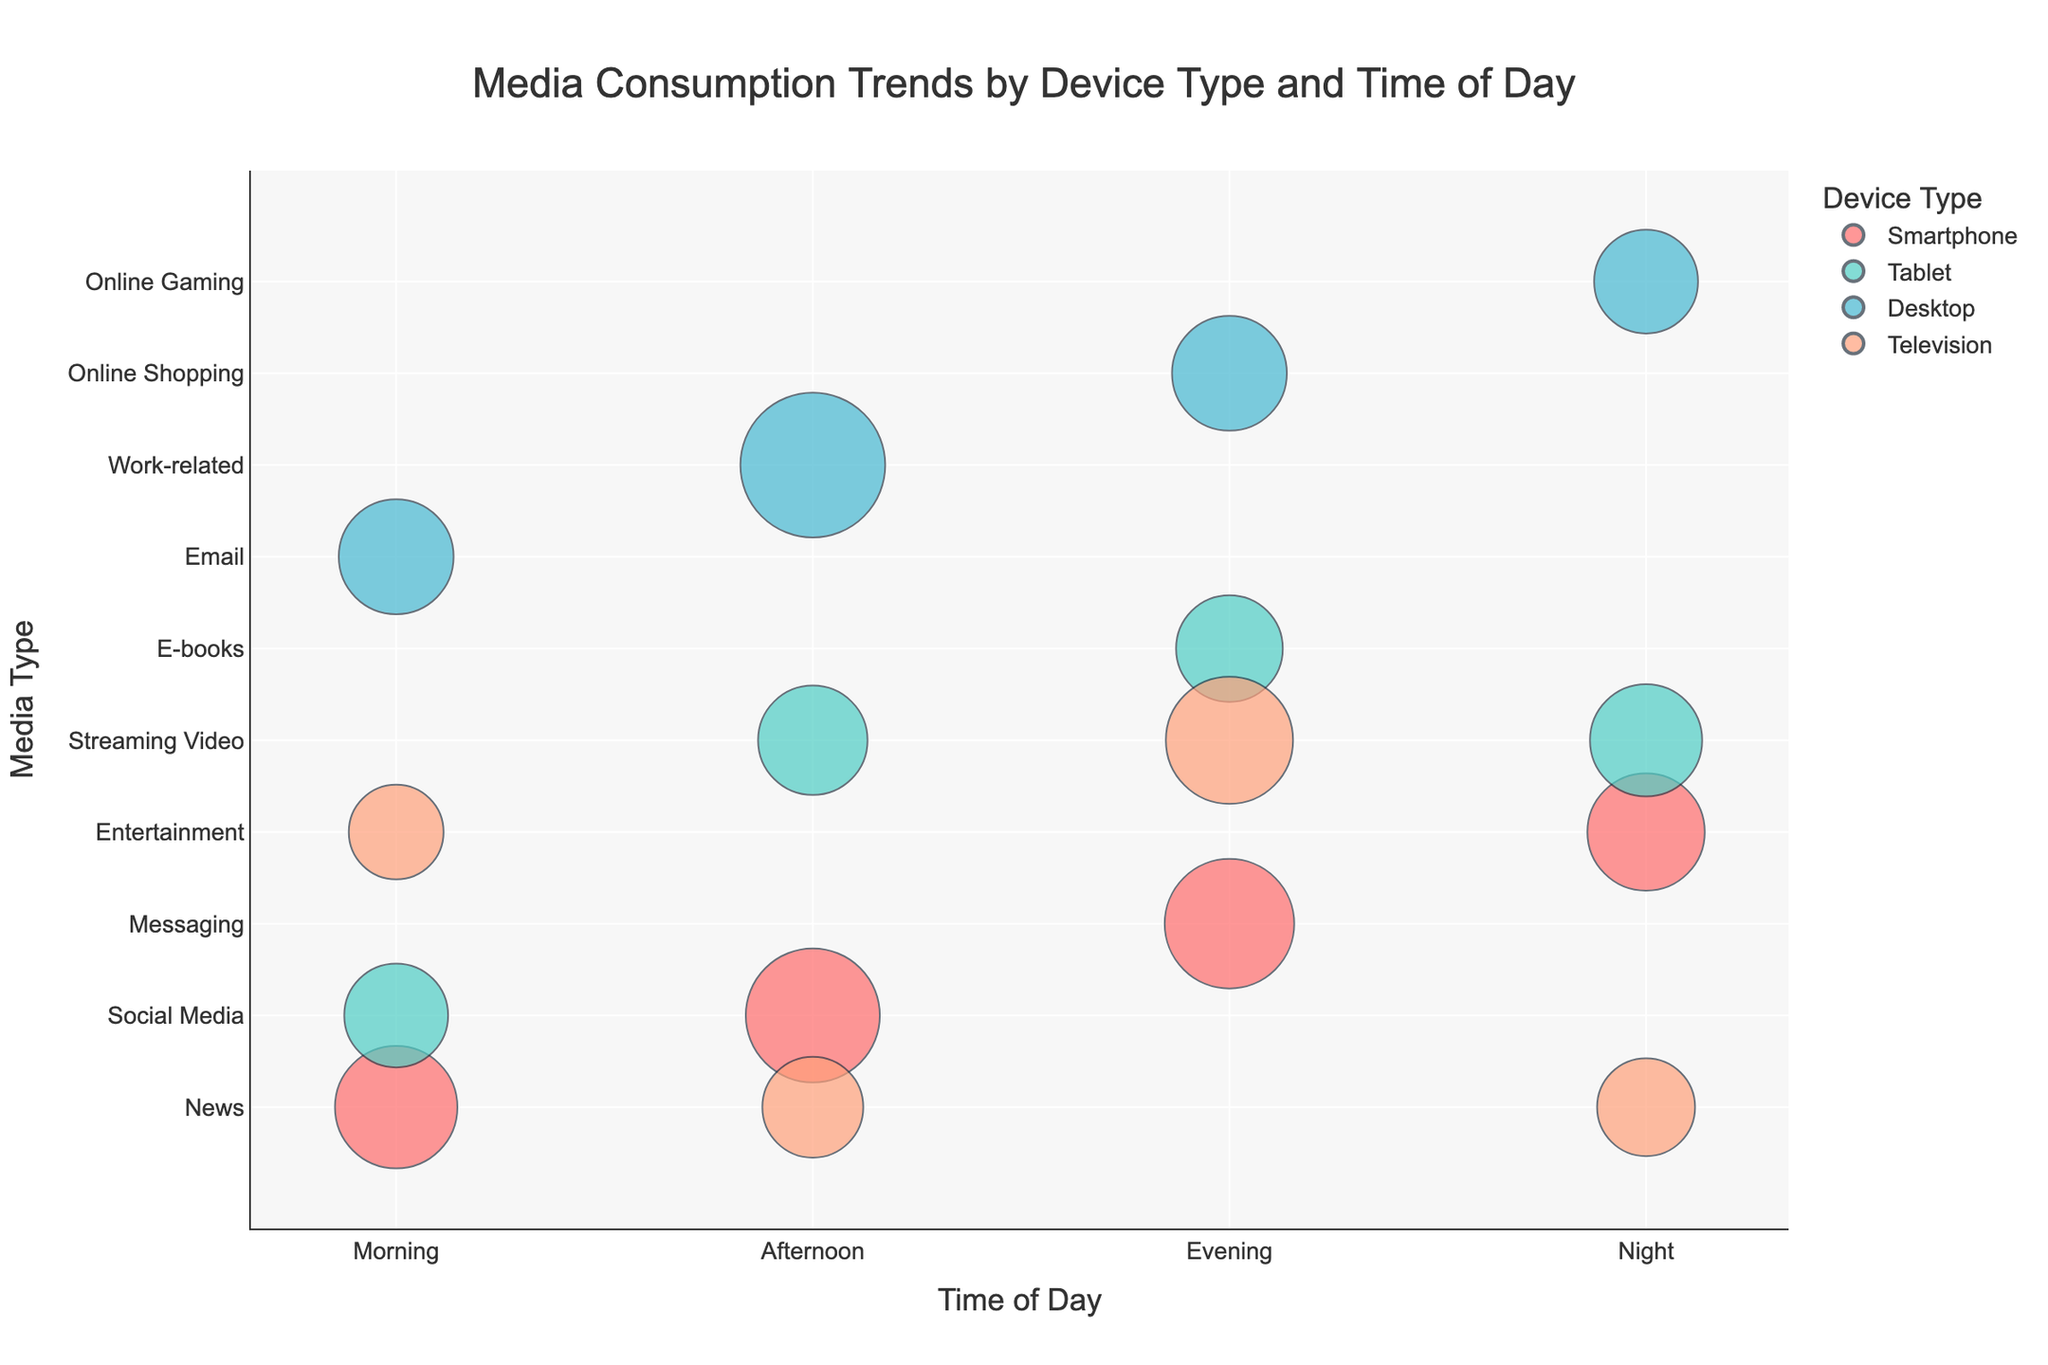What is the title of the chart? The title of the chart is displayed prominently at the top.
Answer: Media Consumption Trends by Device Type and Time of Day Which device type is represented by the color red? By looking at the color map, the red color corresponds to one of the device types.
Answer: Smartphone How many users engage with online shopping on desktops during the evening? Find the bubble corresponding to evening, desktop, and online shopping, then look at the user count displayed.
Answer: 2200 What is the average duration for streaming video on tablets during the afternoon? Find the bubble corresponding to afternoon, tablet, and streaming video, and check the hover information for average duration.
Answer: 45 mins Which media type has the highest user count in the afternoon? Compare the sizes of the bubbles in the afternoon time slot to find the one with the largest size.
Answer: Work-related What is the difference in average duration between email consumption on desktops in the morning and online gaming on desktops at night? Look for both data points, check the average duration values, and compute the difference.
Answer: 30 mins During which time of day do smartphones show the highest user count, and for what media type? Compare the sizes of bubbles representing smartphones across different times of the day and identify the highest user count.
Answer: Afternoon, Social Media Which device has the highest average duration for media consumption during the night? Inspect the hover information for all devices during the night and identify the one with the maximum average duration.
Answer: Tablet, Streaming Video Does the user count for messaging on smartphones in the evening exceed the user count for entertainment on smartphones at night? Compare the sizes of the two relevant bubbles to see which is larger.
Answer: Yes What is the total user count for all media types on desktops during the morning? Sum the user counts for all media types consumed on desktops during the morning by finding the relevant bubble sizes.
Answer: 2200 